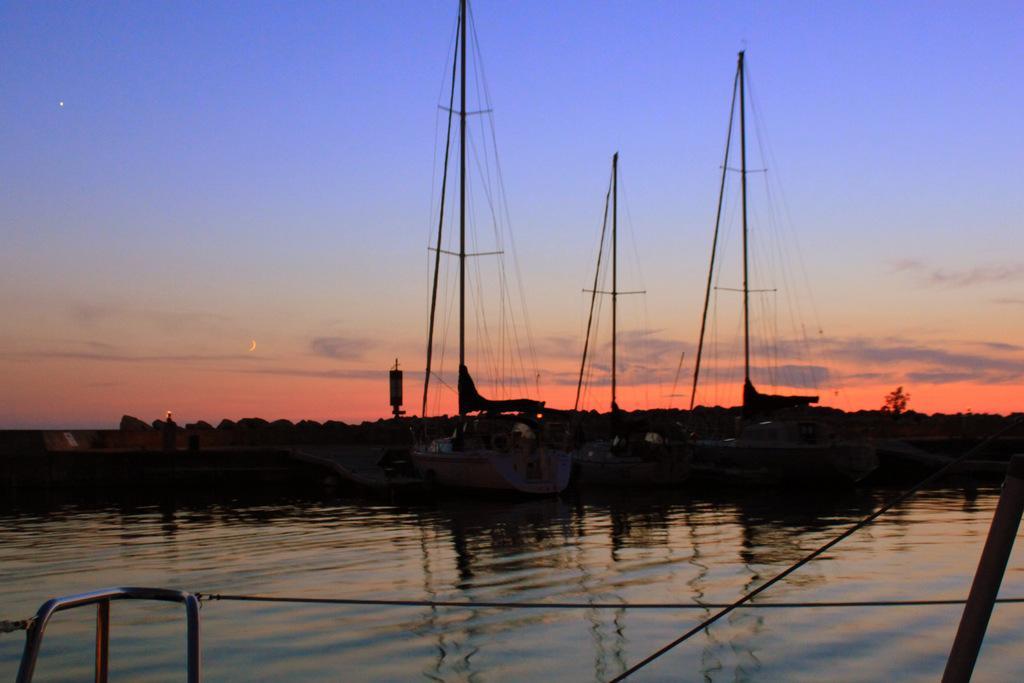Can you describe this image briefly? In the background we can see the moon and clouds in the sky, tree. In this picture we can see the water, boats, ropes. At the bottom portion of the picture we can see the rods and ropes. 